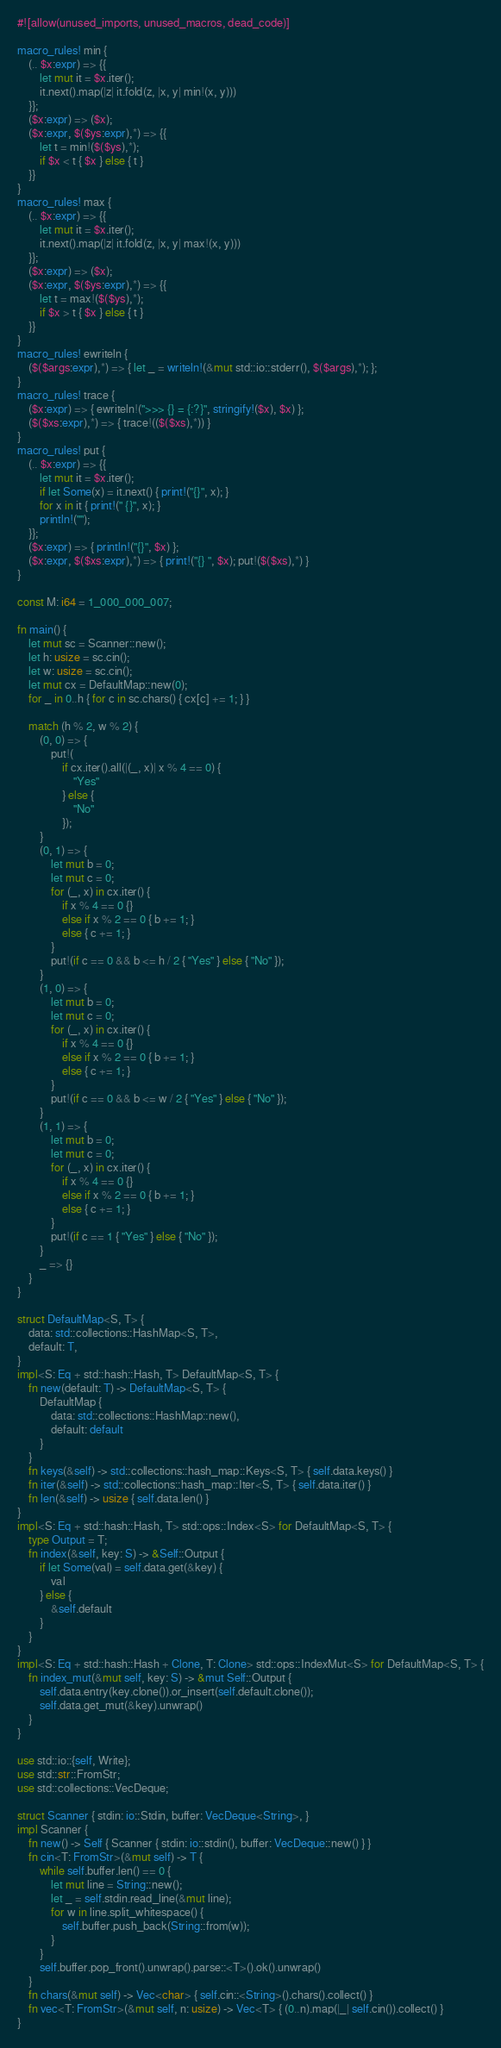<code> <loc_0><loc_0><loc_500><loc_500><_Rust_>#![allow(unused_imports, unused_macros, dead_code)]

macro_rules! min {
    (.. $x:expr) => {{
        let mut it = $x.iter();
        it.next().map(|z| it.fold(z, |x, y| min!(x, y)))
    }};
    ($x:expr) => ($x);
    ($x:expr, $($ys:expr),*) => {{
        let t = min!($($ys),*);
        if $x < t { $x } else { t }
    }}
}
macro_rules! max {
    (.. $x:expr) => {{
        let mut it = $x.iter();
        it.next().map(|z| it.fold(z, |x, y| max!(x, y)))
    }};
    ($x:expr) => ($x);
    ($x:expr, $($ys:expr),*) => {{
        let t = max!($($ys),*);
        if $x > t { $x } else { t }
    }}
}
macro_rules! ewriteln {
    ($($args:expr),*) => { let _ = writeln!(&mut std::io::stderr(), $($args),*); };
}
macro_rules! trace {
    ($x:expr) => { ewriteln!(">>> {} = {:?}", stringify!($x), $x) };
    ($($xs:expr),*) => { trace!(($($xs),*)) }
}
macro_rules! put {
    (.. $x:expr) => {{
        let mut it = $x.iter();
        if let Some(x) = it.next() { print!("{}", x); }
        for x in it { print!(" {}", x); }
        println!("");
    }};
    ($x:expr) => { println!("{}", $x) };
    ($x:expr, $($xs:expr),*) => { print!("{} ", $x); put!($($xs),*) }
}

const M: i64 = 1_000_000_007;

fn main() {
    let mut sc = Scanner::new();
    let h: usize = sc.cin();
    let w: usize = sc.cin();
    let mut cx = DefaultMap::new(0);
    for _ in 0..h { for c in sc.chars() { cx[c] += 1; } }

    match (h % 2, w % 2) {
        (0, 0) => {
            put!(
                if cx.iter().all(|(_, x)| x % 4 == 0) {
                    "Yes"
                } else {
                    "No"
                });
        }
        (0, 1) => {
            let mut b = 0;
            let mut c = 0;
            for (_, x) in cx.iter() {
                if x % 4 == 0 {}
                else if x % 2 == 0 { b += 1; }
                else { c += 1; }
            }
            put!(if c == 0 && b <= h / 2 { "Yes" } else { "No" });
        }
        (1, 0) => {
            let mut b = 0;
            let mut c = 0;
            for (_, x) in cx.iter() {
                if x % 4 == 0 {}
                else if x % 2 == 0 { b += 1; }
                else { c += 1; }
            }
            put!(if c == 0 && b <= w / 2 { "Yes" } else { "No" });
        }
        (1, 1) => {
            let mut b = 0;
            let mut c = 0;
            for (_, x) in cx.iter() {
                if x % 4 == 0 {}
                else if x % 2 == 0 { b += 1; }
                else { c += 1; }
            }
            put!(if c == 1 { "Yes" } else { "No" });
        }
        _ => {}
    }
}

struct DefaultMap<S, T> {
    data: std::collections::HashMap<S, T>,
    default: T,
}
impl<S: Eq + std::hash::Hash, T> DefaultMap<S, T> {
    fn new(default: T) -> DefaultMap<S, T> {
        DefaultMap {
            data: std::collections::HashMap::new(),
            default: default
        }
    }
    fn keys(&self) -> std::collections::hash_map::Keys<S, T> { self.data.keys() }
    fn iter(&self) -> std::collections::hash_map::Iter<S, T> { self.data.iter() }
    fn len(&self) -> usize { self.data.len() }
}
impl<S: Eq + std::hash::Hash, T> std::ops::Index<S> for DefaultMap<S, T> {
    type Output = T;
    fn index(&self, key: S) -> &Self::Output {
        if let Some(val) = self.data.get(&key) {
            val
        } else {
            &self.default
        }
    }
}
impl<S: Eq + std::hash::Hash + Clone, T: Clone> std::ops::IndexMut<S> for DefaultMap<S, T> {
    fn index_mut(&mut self, key: S) -> &mut Self::Output {
        self.data.entry(key.clone()).or_insert(self.default.clone());
        self.data.get_mut(&key).unwrap()
    }
}

use std::io::{self, Write};
use std::str::FromStr;
use std::collections::VecDeque;

struct Scanner { stdin: io::Stdin, buffer: VecDeque<String>, }
impl Scanner {
    fn new() -> Self { Scanner { stdin: io::stdin(), buffer: VecDeque::new() } }
    fn cin<T: FromStr>(&mut self) -> T {
        while self.buffer.len() == 0 {
            let mut line = String::new();
            let _ = self.stdin.read_line(&mut line);
            for w in line.split_whitespace() {
                self.buffer.push_back(String::from(w));
            }
        }
        self.buffer.pop_front().unwrap().parse::<T>().ok().unwrap()
    }
    fn chars(&mut self) -> Vec<char> { self.cin::<String>().chars().collect() }
    fn vec<T: FromStr>(&mut self, n: usize) -> Vec<T> { (0..n).map(|_| self.cin()).collect() }
}
</code> 